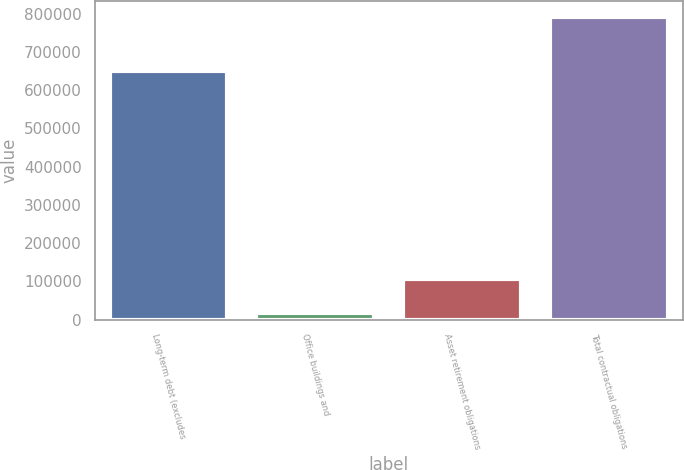<chart> <loc_0><loc_0><loc_500><loc_500><bar_chart><fcel>Long-term debt (excludes<fcel>Office buildings and<fcel>Asset retirement obligations<fcel>Total contractual obligations<nl><fcel>650000<fcel>17863<fcel>105479<fcel>792342<nl></chart> 